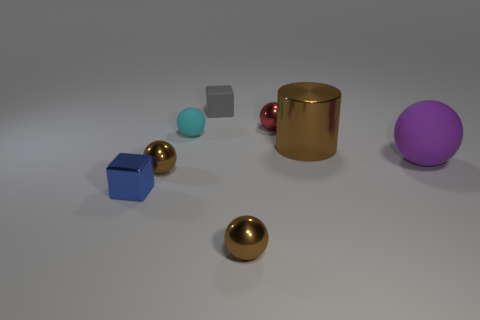What number of tiny things have the same color as the cylinder?
Make the answer very short. 2. Is there another big object of the same shape as the gray object?
Ensure brevity in your answer.  No. There is a brown ball that is in front of the blue metallic object; is it the same size as the matte ball that is behind the big rubber ball?
Provide a short and direct response. Yes. Are there fewer small metal spheres left of the gray matte object than cubes behind the small cyan matte ball?
Ensure brevity in your answer.  No. The tiny object that is in front of the small blue block is what color?
Provide a succinct answer. Brown. Is the color of the big rubber sphere the same as the small metallic block?
Give a very brief answer. No. There is a tiny brown ball that is right of the small brown shiny object that is behind the blue block; what number of tiny blue shiny blocks are behind it?
Keep it short and to the point. 1. The purple matte object has what size?
Provide a succinct answer. Large. What material is the blue thing that is the same size as the red metal thing?
Ensure brevity in your answer.  Metal. There is a small cyan rubber thing; how many matte things are on the right side of it?
Make the answer very short. 2. 